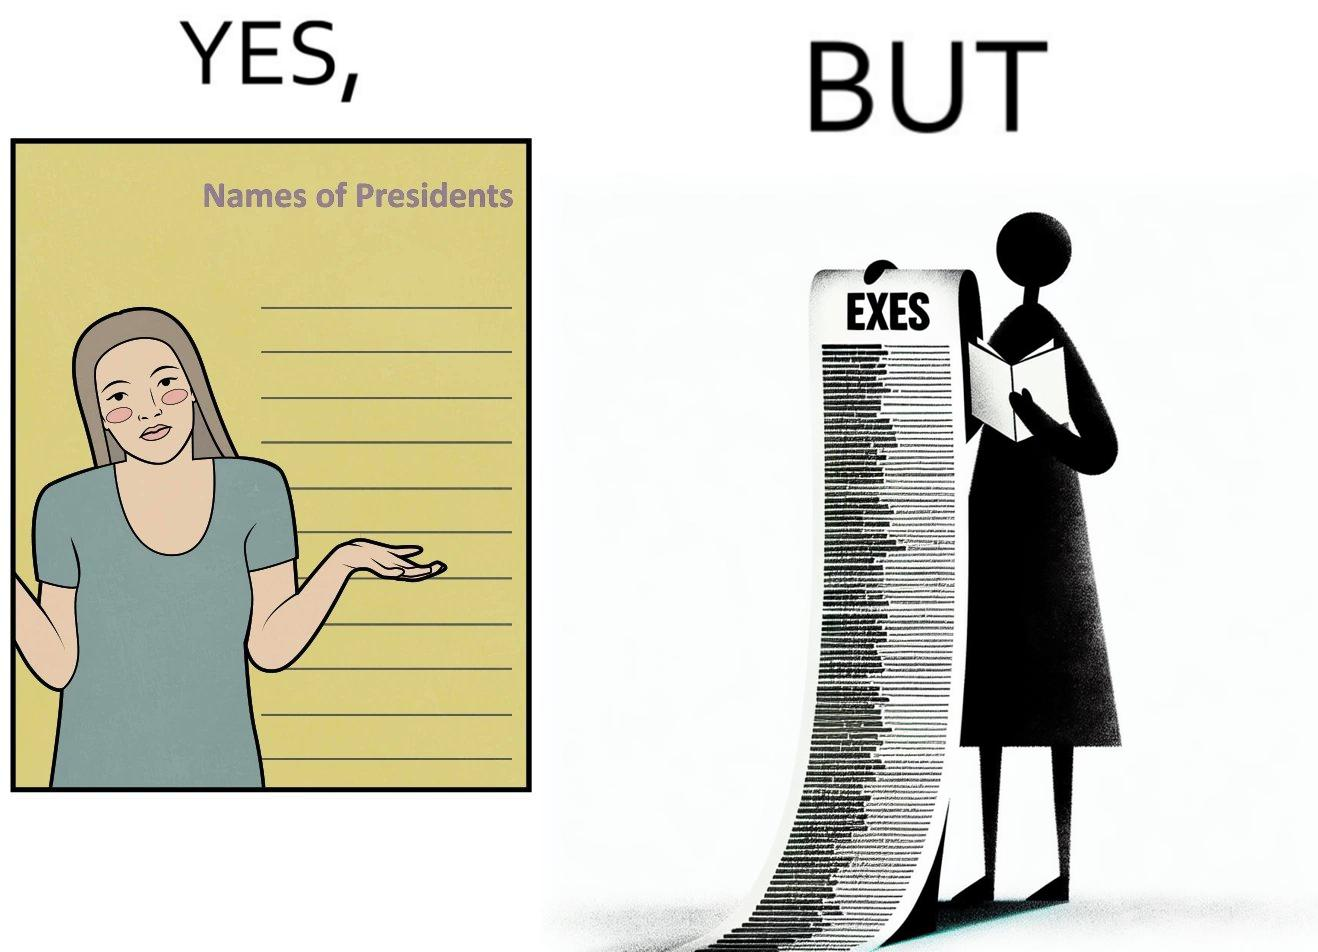Explain the humor or irony in this image. The images are funny since it shows how people tend to forget the important details like names of presidents but remember the useless ones, like forgetting names of presidents but remembering the names of their exes in this example 